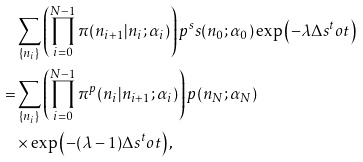<formula> <loc_0><loc_0><loc_500><loc_500>& \sum _ { \{ n _ { i } \} } \left ( \prod _ { i = 0 } ^ { N - 1 } \pi ( n _ { i + 1 } | n _ { i } ; \alpha _ { i } ) \right ) p ^ { s } s ( n _ { 0 } ; \alpha _ { 0 } ) \exp \left ( - \lambda \Delta s ^ { t } o t \right ) \\ = & \sum _ { \{ n _ { i } \} } \left ( \prod _ { i = 0 } ^ { N - 1 } \pi ^ { p } ( n _ { i } | n _ { i + 1 } ; \alpha _ { i } ) \right ) p ( n _ { N } ; \alpha _ { N } ) \\ & \times \exp \left ( - ( \lambda - 1 ) \Delta s ^ { t } o t \right ) ,</formula> 